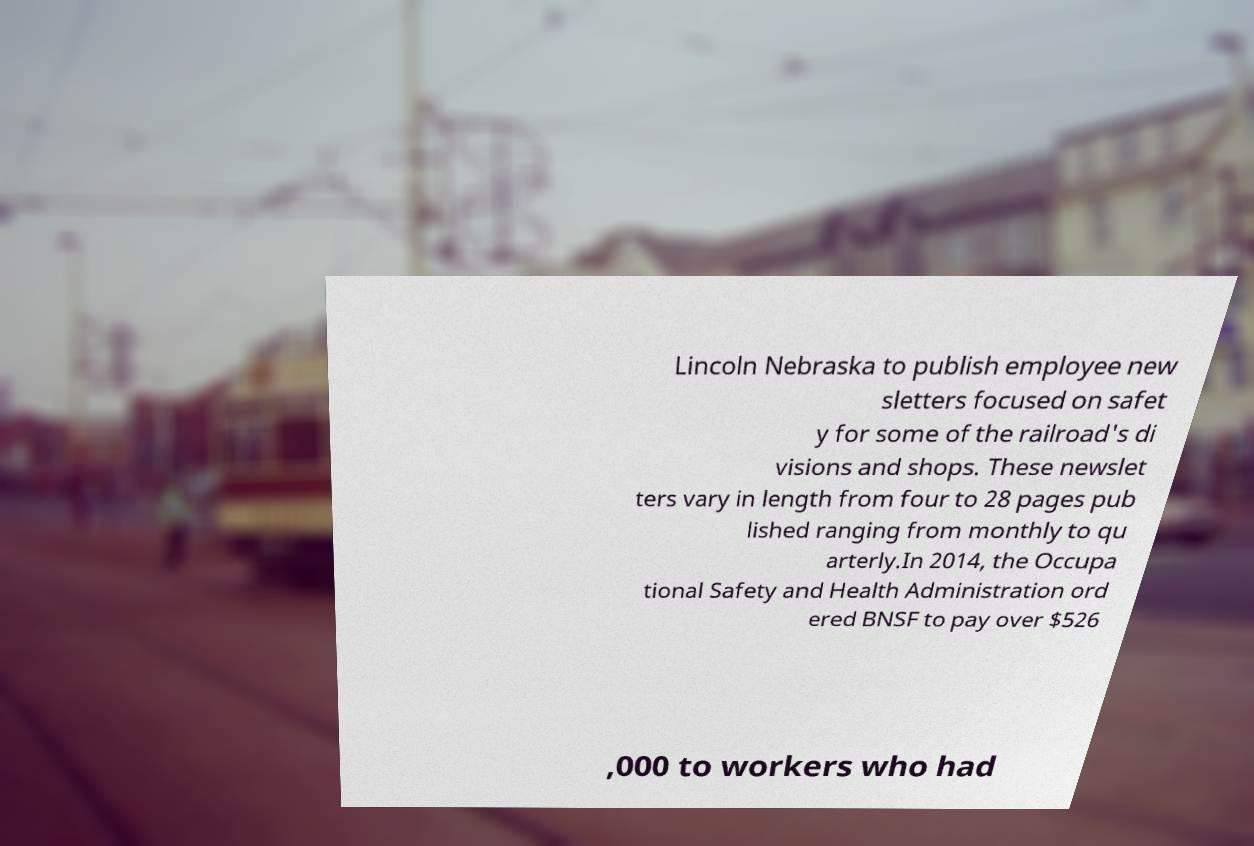I need the written content from this picture converted into text. Can you do that? Lincoln Nebraska to publish employee new sletters focused on safet y for some of the railroad's di visions and shops. These newslet ters vary in length from four to 28 pages pub lished ranging from monthly to qu arterly.In 2014, the Occupa tional Safety and Health Administration ord ered BNSF to pay over $526 ,000 to workers who had 